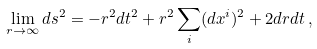Convert formula to latex. <formula><loc_0><loc_0><loc_500><loc_500>\lim _ { r \to \infty } d s ^ { 2 } = - r ^ { 2 } d t ^ { 2 } + r ^ { 2 } \sum _ { i } ( d x ^ { i } ) ^ { 2 } + 2 d r d t \, ,</formula> 